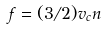Convert formula to latex. <formula><loc_0><loc_0><loc_500><loc_500>f = ( 3 / 2 ) v _ { c } n</formula> 